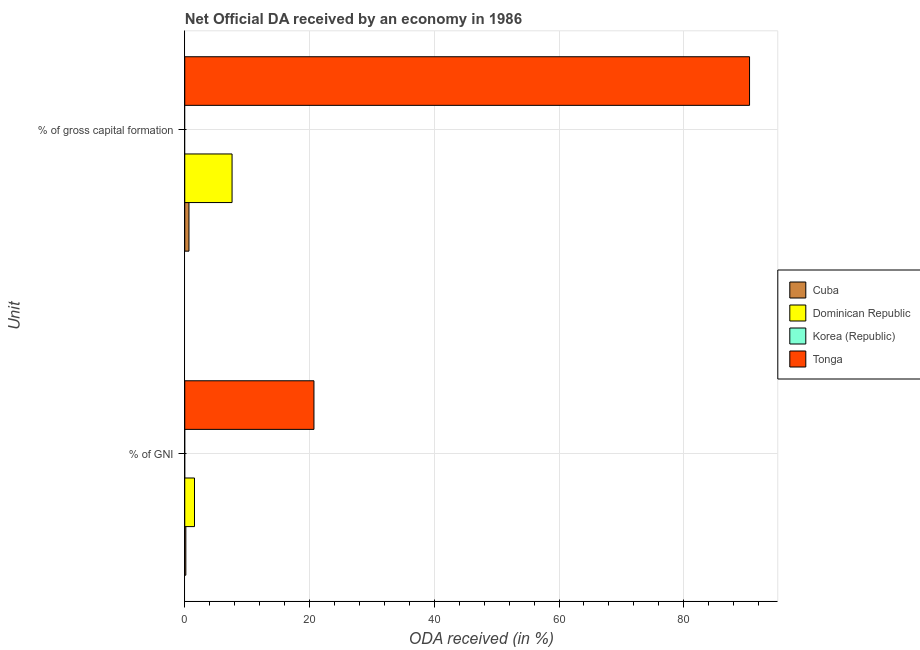How many different coloured bars are there?
Keep it short and to the point. 3. Are the number of bars per tick equal to the number of legend labels?
Provide a short and direct response. No. Are the number of bars on each tick of the Y-axis equal?
Ensure brevity in your answer.  Yes. How many bars are there on the 1st tick from the top?
Ensure brevity in your answer.  3. How many bars are there on the 2nd tick from the bottom?
Your response must be concise. 3. What is the label of the 2nd group of bars from the top?
Ensure brevity in your answer.  % of GNI. What is the oda received as percentage of gross capital formation in Tonga?
Your answer should be compact. 90.54. Across all countries, what is the maximum oda received as percentage of gross capital formation?
Make the answer very short. 90.54. Across all countries, what is the minimum oda received as percentage of gni?
Keep it short and to the point. 0. In which country was the oda received as percentage of gni maximum?
Provide a short and direct response. Tonga. What is the total oda received as percentage of gross capital formation in the graph?
Ensure brevity in your answer.  98.8. What is the difference between the oda received as percentage of gni in Tonga and that in Cuba?
Keep it short and to the point. 20.54. What is the difference between the oda received as percentage of gni in Cuba and the oda received as percentage of gross capital formation in Korea (Republic)?
Give a very brief answer. 0.18. What is the average oda received as percentage of gni per country?
Ensure brevity in your answer.  5.61. What is the difference between the oda received as percentage of gni and oda received as percentage of gross capital formation in Tonga?
Provide a succinct answer. -69.83. In how many countries, is the oda received as percentage of gni greater than 80 %?
Give a very brief answer. 0. What is the ratio of the oda received as percentage of gross capital formation in Dominican Republic to that in Cuba?
Ensure brevity in your answer.  11.23. Is the oda received as percentage of gross capital formation in Cuba less than that in Tonga?
Keep it short and to the point. Yes. In how many countries, is the oda received as percentage of gni greater than the average oda received as percentage of gni taken over all countries?
Your answer should be compact. 1. Are all the bars in the graph horizontal?
Your response must be concise. Yes. How many countries are there in the graph?
Ensure brevity in your answer.  4. What is the difference between two consecutive major ticks on the X-axis?
Your response must be concise. 20. Does the graph contain grids?
Offer a terse response. Yes. How are the legend labels stacked?
Your response must be concise. Vertical. What is the title of the graph?
Make the answer very short. Net Official DA received by an economy in 1986. What is the label or title of the X-axis?
Offer a very short reply. ODA received (in %). What is the label or title of the Y-axis?
Offer a terse response. Unit. What is the ODA received (in %) of Cuba in % of GNI?
Ensure brevity in your answer.  0.18. What is the ODA received (in %) of Dominican Republic in % of GNI?
Ensure brevity in your answer.  1.56. What is the ODA received (in %) of Korea (Republic) in % of GNI?
Your response must be concise. 0. What is the ODA received (in %) in Tonga in % of GNI?
Give a very brief answer. 20.71. What is the ODA received (in %) of Cuba in % of gross capital formation?
Keep it short and to the point. 0.68. What is the ODA received (in %) in Dominican Republic in % of gross capital formation?
Ensure brevity in your answer.  7.58. What is the ODA received (in %) in Tonga in % of gross capital formation?
Offer a very short reply. 90.54. Across all Unit, what is the maximum ODA received (in %) of Cuba?
Provide a short and direct response. 0.68. Across all Unit, what is the maximum ODA received (in %) of Dominican Republic?
Provide a succinct answer. 7.58. Across all Unit, what is the maximum ODA received (in %) in Tonga?
Ensure brevity in your answer.  90.54. Across all Unit, what is the minimum ODA received (in %) in Cuba?
Your answer should be compact. 0.18. Across all Unit, what is the minimum ODA received (in %) in Dominican Republic?
Offer a terse response. 1.56. Across all Unit, what is the minimum ODA received (in %) of Tonga?
Provide a short and direct response. 20.71. What is the total ODA received (in %) of Cuba in the graph?
Give a very brief answer. 0.85. What is the total ODA received (in %) of Dominican Republic in the graph?
Your answer should be very brief. 9.15. What is the total ODA received (in %) in Korea (Republic) in the graph?
Keep it short and to the point. 0. What is the total ODA received (in %) in Tonga in the graph?
Make the answer very short. 111.25. What is the difference between the ODA received (in %) of Cuba in % of GNI and that in % of gross capital formation?
Your answer should be compact. -0.5. What is the difference between the ODA received (in %) in Dominican Republic in % of GNI and that in % of gross capital formation?
Give a very brief answer. -6.02. What is the difference between the ODA received (in %) in Tonga in % of GNI and that in % of gross capital formation?
Ensure brevity in your answer.  -69.83. What is the difference between the ODA received (in %) of Cuba in % of GNI and the ODA received (in %) of Dominican Republic in % of gross capital formation?
Offer a very short reply. -7.41. What is the difference between the ODA received (in %) of Cuba in % of GNI and the ODA received (in %) of Tonga in % of gross capital formation?
Offer a very short reply. -90.37. What is the difference between the ODA received (in %) in Dominican Republic in % of GNI and the ODA received (in %) in Tonga in % of gross capital formation?
Provide a succinct answer. -88.98. What is the average ODA received (in %) in Cuba per Unit?
Offer a very short reply. 0.43. What is the average ODA received (in %) in Dominican Republic per Unit?
Your answer should be compact. 4.57. What is the average ODA received (in %) in Korea (Republic) per Unit?
Offer a very short reply. 0. What is the average ODA received (in %) of Tonga per Unit?
Your answer should be very brief. 55.63. What is the difference between the ODA received (in %) in Cuba and ODA received (in %) in Dominican Republic in % of GNI?
Make the answer very short. -1.39. What is the difference between the ODA received (in %) of Cuba and ODA received (in %) of Tonga in % of GNI?
Keep it short and to the point. -20.54. What is the difference between the ODA received (in %) in Dominican Republic and ODA received (in %) in Tonga in % of GNI?
Your response must be concise. -19.15. What is the difference between the ODA received (in %) in Cuba and ODA received (in %) in Dominican Republic in % of gross capital formation?
Keep it short and to the point. -6.91. What is the difference between the ODA received (in %) in Cuba and ODA received (in %) in Tonga in % of gross capital formation?
Keep it short and to the point. -89.87. What is the difference between the ODA received (in %) in Dominican Republic and ODA received (in %) in Tonga in % of gross capital formation?
Your answer should be very brief. -82.96. What is the ratio of the ODA received (in %) of Cuba in % of GNI to that in % of gross capital formation?
Ensure brevity in your answer.  0.26. What is the ratio of the ODA received (in %) in Dominican Republic in % of GNI to that in % of gross capital formation?
Give a very brief answer. 0.21. What is the ratio of the ODA received (in %) of Tonga in % of GNI to that in % of gross capital formation?
Your response must be concise. 0.23. What is the difference between the highest and the second highest ODA received (in %) of Cuba?
Ensure brevity in your answer.  0.5. What is the difference between the highest and the second highest ODA received (in %) in Dominican Republic?
Give a very brief answer. 6.02. What is the difference between the highest and the second highest ODA received (in %) in Tonga?
Your answer should be very brief. 69.83. What is the difference between the highest and the lowest ODA received (in %) in Cuba?
Offer a very short reply. 0.5. What is the difference between the highest and the lowest ODA received (in %) in Dominican Republic?
Provide a succinct answer. 6.02. What is the difference between the highest and the lowest ODA received (in %) in Tonga?
Provide a succinct answer. 69.83. 